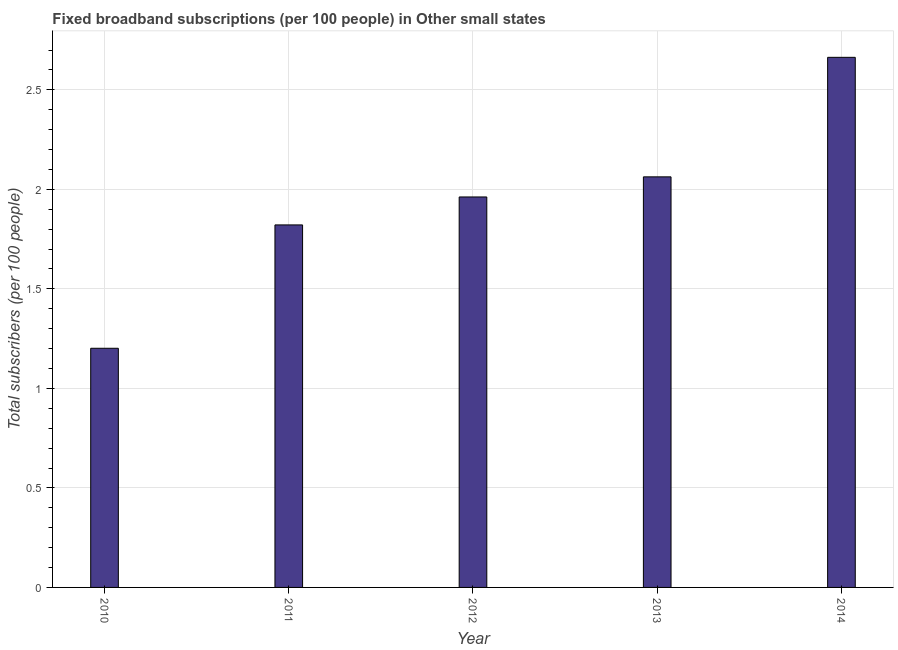What is the title of the graph?
Make the answer very short. Fixed broadband subscriptions (per 100 people) in Other small states. What is the label or title of the X-axis?
Offer a terse response. Year. What is the label or title of the Y-axis?
Offer a terse response. Total subscribers (per 100 people). What is the total number of fixed broadband subscriptions in 2010?
Your answer should be compact. 1.2. Across all years, what is the maximum total number of fixed broadband subscriptions?
Provide a short and direct response. 2.66. Across all years, what is the minimum total number of fixed broadband subscriptions?
Keep it short and to the point. 1.2. In which year was the total number of fixed broadband subscriptions minimum?
Ensure brevity in your answer.  2010. What is the sum of the total number of fixed broadband subscriptions?
Keep it short and to the point. 9.71. What is the difference between the total number of fixed broadband subscriptions in 2011 and 2012?
Keep it short and to the point. -0.14. What is the average total number of fixed broadband subscriptions per year?
Offer a terse response. 1.94. What is the median total number of fixed broadband subscriptions?
Provide a short and direct response. 1.96. In how many years, is the total number of fixed broadband subscriptions greater than 1 ?
Provide a succinct answer. 5. Do a majority of the years between 2014 and 2013 (inclusive) have total number of fixed broadband subscriptions greater than 0.4 ?
Ensure brevity in your answer.  No. What is the ratio of the total number of fixed broadband subscriptions in 2010 to that in 2013?
Your response must be concise. 0.58. What is the difference between the highest and the second highest total number of fixed broadband subscriptions?
Provide a succinct answer. 0.6. What is the difference between the highest and the lowest total number of fixed broadband subscriptions?
Make the answer very short. 1.46. How many bars are there?
Offer a terse response. 5. Are all the bars in the graph horizontal?
Make the answer very short. No. How many years are there in the graph?
Your answer should be very brief. 5. What is the Total subscribers (per 100 people) of 2010?
Give a very brief answer. 1.2. What is the Total subscribers (per 100 people) in 2011?
Provide a succinct answer. 1.82. What is the Total subscribers (per 100 people) of 2012?
Give a very brief answer. 1.96. What is the Total subscribers (per 100 people) in 2013?
Your answer should be compact. 2.06. What is the Total subscribers (per 100 people) of 2014?
Make the answer very short. 2.66. What is the difference between the Total subscribers (per 100 people) in 2010 and 2011?
Offer a very short reply. -0.62. What is the difference between the Total subscribers (per 100 people) in 2010 and 2012?
Your answer should be very brief. -0.76. What is the difference between the Total subscribers (per 100 people) in 2010 and 2013?
Provide a succinct answer. -0.86. What is the difference between the Total subscribers (per 100 people) in 2010 and 2014?
Make the answer very short. -1.46. What is the difference between the Total subscribers (per 100 people) in 2011 and 2012?
Provide a short and direct response. -0.14. What is the difference between the Total subscribers (per 100 people) in 2011 and 2013?
Your response must be concise. -0.24. What is the difference between the Total subscribers (per 100 people) in 2011 and 2014?
Give a very brief answer. -0.84. What is the difference between the Total subscribers (per 100 people) in 2012 and 2013?
Provide a succinct answer. -0.1. What is the difference between the Total subscribers (per 100 people) in 2012 and 2014?
Provide a succinct answer. -0.7. What is the difference between the Total subscribers (per 100 people) in 2013 and 2014?
Keep it short and to the point. -0.6. What is the ratio of the Total subscribers (per 100 people) in 2010 to that in 2011?
Offer a very short reply. 0.66. What is the ratio of the Total subscribers (per 100 people) in 2010 to that in 2012?
Your answer should be compact. 0.61. What is the ratio of the Total subscribers (per 100 people) in 2010 to that in 2013?
Keep it short and to the point. 0.58. What is the ratio of the Total subscribers (per 100 people) in 2010 to that in 2014?
Your response must be concise. 0.45. What is the ratio of the Total subscribers (per 100 people) in 2011 to that in 2012?
Ensure brevity in your answer.  0.93. What is the ratio of the Total subscribers (per 100 people) in 2011 to that in 2013?
Keep it short and to the point. 0.88. What is the ratio of the Total subscribers (per 100 people) in 2011 to that in 2014?
Make the answer very short. 0.68. What is the ratio of the Total subscribers (per 100 people) in 2012 to that in 2013?
Your answer should be very brief. 0.95. What is the ratio of the Total subscribers (per 100 people) in 2012 to that in 2014?
Offer a very short reply. 0.74. What is the ratio of the Total subscribers (per 100 people) in 2013 to that in 2014?
Provide a succinct answer. 0.78. 